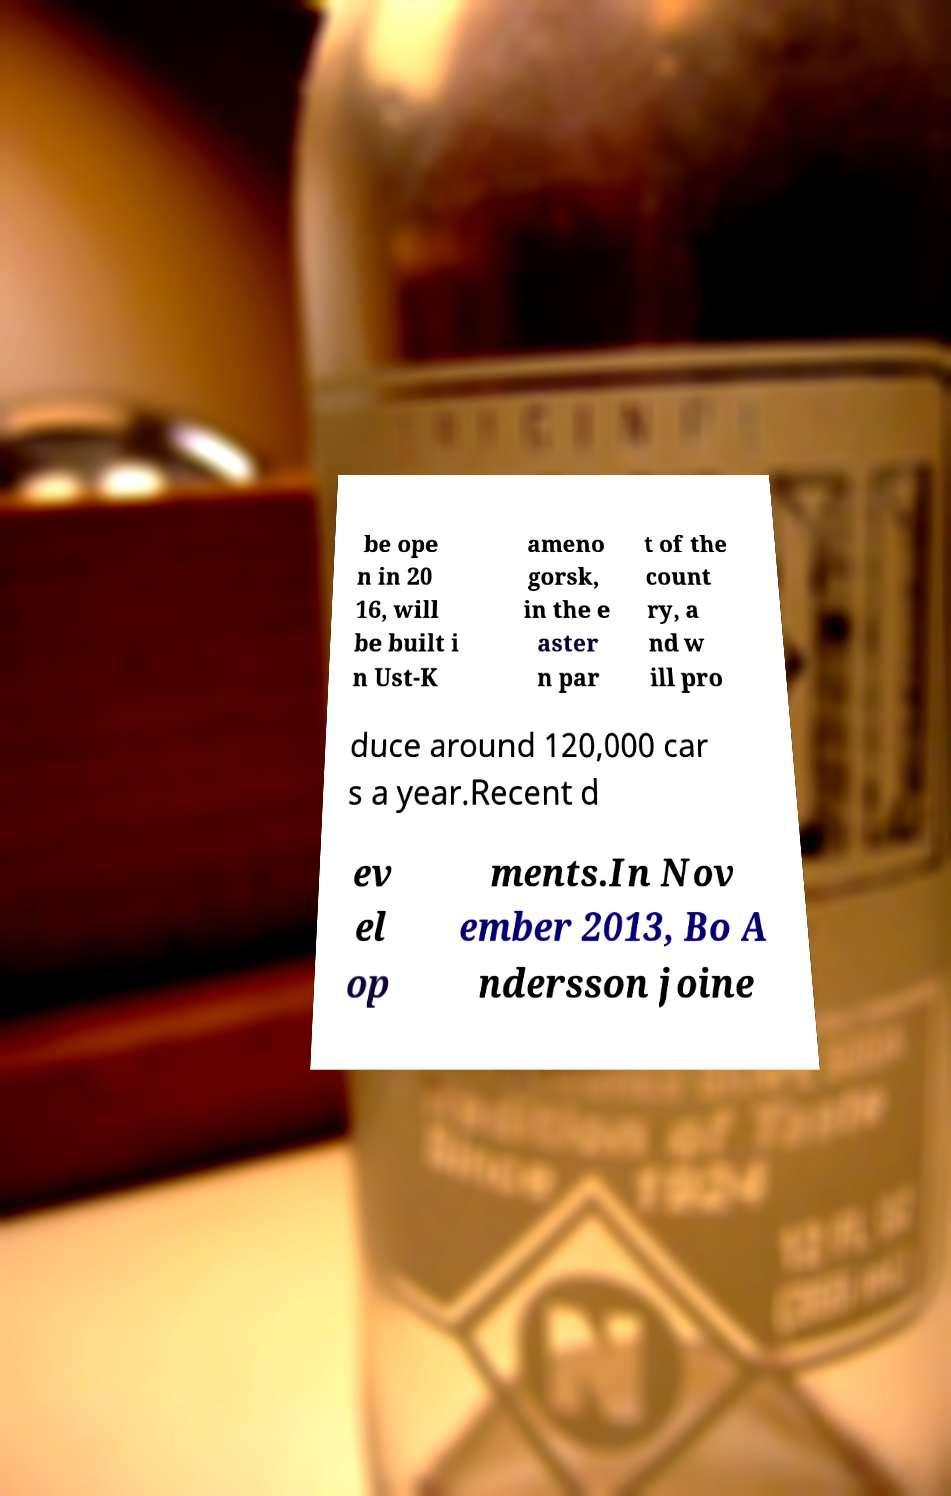Please read and relay the text visible in this image. What does it say? be ope n in 20 16, will be built i n Ust-K ameno gorsk, in the e aster n par t of the count ry, a nd w ill pro duce around 120,000 car s a year.Recent d ev el op ments.In Nov ember 2013, Bo A ndersson joine 